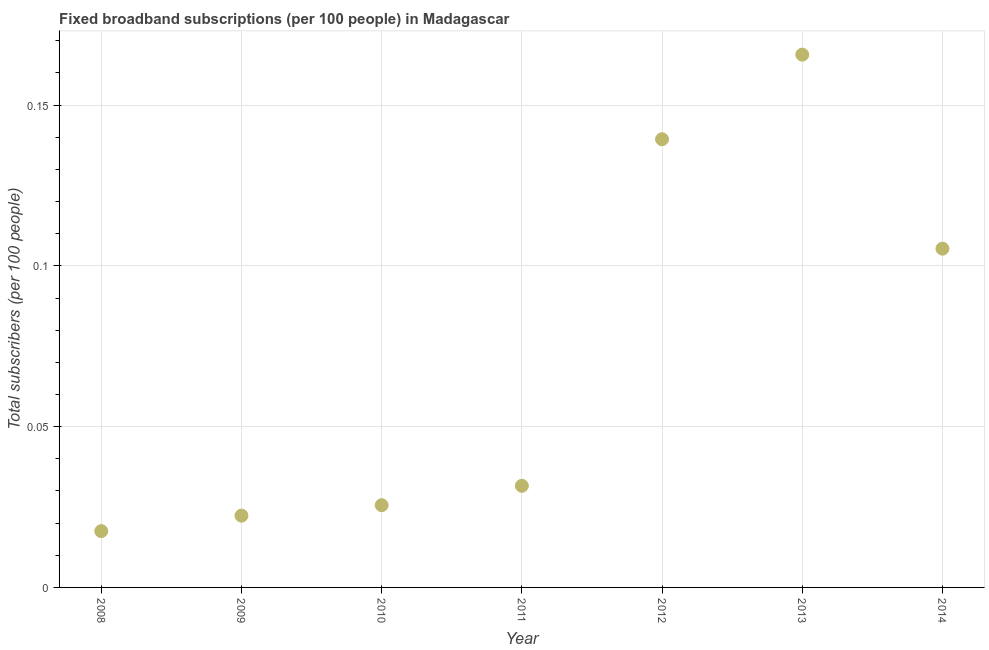What is the total number of fixed broadband subscriptions in 2011?
Offer a very short reply. 0.03. Across all years, what is the maximum total number of fixed broadband subscriptions?
Your answer should be compact. 0.17. Across all years, what is the minimum total number of fixed broadband subscriptions?
Ensure brevity in your answer.  0.02. What is the sum of the total number of fixed broadband subscriptions?
Ensure brevity in your answer.  0.51. What is the difference between the total number of fixed broadband subscriptions in 2012 and 2014?
Your response must be concise. 0.03. What is the average total number of fixed broadband subscriptions per year?
Offer a terse response. 0.07. What is the median total number of fixed broadband subscriptions?
Provide a succinct answer. 0.03. In how many years, is the total number of fixed broadband subscriptions greater than 0.15000000000000002 ?
Offer a very short reply. 1. Do a majority of the years between 2011 and 2010 (inclusive) have total number of fixed broadband subscriptions greater than 0.11 ?
Offer a terse response. No. What is the ratio of the total number of fixed broadband subscriptions in 2008 to that in 2014?
Your answer should be compact. 0.17. Is the difference between the total number of fixed broadband subscriptions in 2009 and 2014 greater than the difference between any two years?
Keep it short and to the point. No. What is the difference between the highest and the second highest total number of fixed broadband subscriptions?
Provide a short and direct response. 0.03. What is the difference between the highest and the lowest total number of fixed broadband subscriptions?
Your response must be concise. 0.15. In how many years, is the total number of fixed broadband subscriptions greater than the average total number of fixed broadband subscriptions taken over all years?
Keep it short and to the point. 3. How many years are there in the graph?
Your response must be concise. 7. What is the difference between two consecutive major ticks on the Y-axis?
Your answer should be compact. 0.05. Are the values on the major ticks of Y-axis written in scientific E-notation?
Your response must be concise. No. Does the graph contain any zero values?
Provide a short and direct response. No. What is the title of the graph?
Make the answer very short. Fixed broadband subscriptions (per 100 people) in Madagascar. What is the label or title of the Y-axis?
Your answer should be very brief. Total subscribers (per 100 people). What is the Total subscribers (per 100 people) in 2008?
Your answer should be very brief. 0.02. What is the Total subscribers (per 100 people) in 2009?
Ensure brevity in your answer.  0.02. What is the Total subscribers (per 100 people) in 2010?
Ensure brevity in your answer.  0.03. What is the Total subscribers (per 100 people) in 2011?
Your response must be concise. 0.03. What is the Total subscribers (per 100 people) in 2012?
Keep it short and to the point. 0.14. What is the Total subscribers (per 100 people) in 2013?
Ensure brevity in your answer.  0.17. What is the Total subscribers (per 100 people) in 2014?
Make the answer very short. 0.11. What is the difference between the Total subscribers (per 100 people) in 2008 and 2009?
Give a very brief answer. -0. What is the difference between the Total subscribers (per 100 people) in 2008 and 2010?
Your answer should be very brief. -0.01. What is the difference between the Total subscribers (per 100 people) in 2008 and 2011?
Offer a terse response. -0.01. What is the difference between the Total subscribers (per 100 people) in 2008 and 2012?
Offer a terse response. -0.12. What is the difference between the Total subscribers (per 100 people) in 2008 and 2013?
Offer a very short reply. -0.15. What is the difference between the Total subscribers (per 100 people) in 2008 and 2014?
Offer a terse response. -0.09. What is the difference between the Total subscribers (per 100 people) in 2009 and 2010?
Provide a succinct answer. -0. What is the difference between the Total subscribers (per 100 people) in 2009 and 2011?
Provide a succinct answer. -0.01. What is the difference between the Total subscribers (per 100 people) in 2009 and 2012?
Your answer should be very brief. -0.12. What is the difference between the Total subscribers (per 100 people) in 2009 and 2013?
Your answer should be very brief. -0.14. What is the difference between the Total subscribers (per 100 people) in 2009 and 2014?
Offer a terse response. -0.08. What is the difference between the Total subscribers (per 100 people) in 2010 and 2011?
Keep it short and to the point. -0.01. What is the difference between the Total subscribers (per 100 people) in 2010 and 2012?
Provide a succinct answer. -0.11. What is the difference between the Total subscribers (per 100 people) in 2010 and 2013?
Keep it short and to the point. -0.14. What is the difference between the Total subscribers (per 100 people) in 2010 and 2014?
Your response must be concise. -0.08. What is the difference between the Total subscribers (per 100 people) in 2011 and 2012?
Offer a terse response. -0.11. What is the difference between the Total subscribers (per 100 people) in 2011 and 2013?
Provide a short and direct response. -0.13. What is the difference between the Total subscribers (per 100 people) in 2011 and 2014?
Provide a short and direct response. -0.07. What is the difference between the Total subscribers (per 100 people) in 2012 and 2013?
Provide a short and direct response. -0.03. What is the difference between the Total subscribers (per 100 people) in 2012 and 2014?
Keep it short and to the point. 0.03. What is the difference between the Total subscribers (per 100 people) in 2013 and 2014?
Ensure brevity in your answer.  0.06. What is the ratio of the Total subscribers (per 100 people) in 2008 to that in 2009?
Give a very brief answer. 0.78. What is the ratio of the Total subscribers (per 100 people) in 2008 to that in 2010?
Make the answer very short. 0.68. What is the ratio of the Total subscribers (per 100 people) in 2008 to that in 2011?
Provide a short and direct response. 0.55. What is the ratio of the Total subscribers (per 100 people) in 2008 to that in 2012?
Provide a succinct answer. 0.13. What is the ratio of the Total subscribers (per 100 people) in 2008 to that in 2013?
Give a very brief answer. 0.11. What is the ratio of the Total subscribers (per 100 people) in 2008 to that in 2014?
Offer a very short reply. 0.17. What is the ratio of the Total subscribers (per 100 people) in 2009 to that in 2010?
Your response must be concise. 0.87. What is the ratio of the Total subscribers (per 100 people) in 2009 to that in 2011?
Offer a very short reply. 0.71. What is the ratio of the Total subscribers (per 100 people) in 2009 to that in 2012?
Provide a short and direct response. 0.16. What is the ratio of the Total subscribers (per 100 people) in 2009 to that in 2013?
Your response must be concise. 0.14. What is the ratio of the Total subscribers (per 100 people) in 2009 to that in 2014?
Your answer should be compact. 0.21. What is the ratio of the Total subscribers (per 100 people) in 2010 to that in 2011?
Provide a succinct answer. 0.81. What is the ratio of the Total subscribers (per 100 people) in 2010 to that in 2012?
Ensure brevity in your answer.  0.18. What is the ratio of the Total subscribers (per 100 people) in 2010 to that in 2013?
Provide a succinct answer. 0.15. What is the ratio of the Total subscribers (per 100 people) in 2010 to that in 2014?
Keep it short and to the point. 0.24. What is the ratio of the Total subscribers (per 100 people) in 2011 to that in 2012?
Provide a succinct answer. 0.23. What is the ratio of the Total subscribers (per 100 people) in 2011 to that in 2013?
Ensure brevity in your answer.  0.19. What is the ratio of the Total subscribers (per 100 people) in 2011 to that in 2014?
Your answer should be compact. 0.3. What is the ratio of the Total subscribers (per 100 people) in 2012 to that in 2013?
Ensure brevity in your answer.  0.84. What is the ratio of the Total subscribers (per 100 people) in 2012 to that in 2014?
Your answer should be very brief. 1.32. What is the ratio of the Total subscribers (per 100 people) in 2013 to that in 2014?
Offer a very short reply. 1.57. 